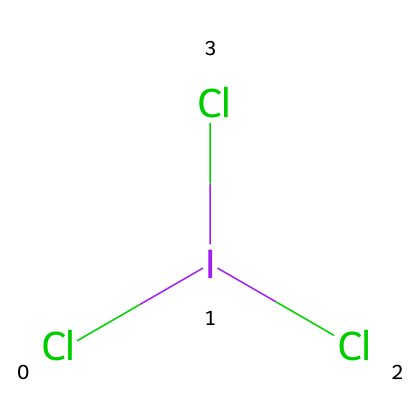What is the total number of chlorine atoms in iodine trichloride? The chemical structure Cl[I](Cl)Cl shows that there are three chlorine atoms bonded to the iodine atom, as indicated by the three Cl groups attached.
Answer: three What is the central atom in the chemical structure of iodine trichloride? Looking at the structure, iodine (I) is the central atom to which the chlorine atoms are bonded; this is evident as it is surrounded by the Cl atoms.
Answer: iodine How many total atoms are present in the chemical structure? Counting all the atoms in Cl[I](Cl)Cl, there are four atoms in total: one iodine (I) and three chlorine (Cl) atoms.
Answer: four Why is iodine trichloride considered a hypervalent compound? Iodine trichloride can accommodate more than eight electrons in its valence shell, specifically having ten electrons (as it is bonded to three chlorine atoms), which is characteristic of hypervalent compounds.
Answer: ten What is a common use of iodine trichloride? Iodine trichloride is commonly utilized in water treatment systems due to its ability to act as a disinfectant.
Answer: disinfectant How many bonds does iodine form in this compound? In the structure Cl[I](Cl)Cl, iodine forms three single bonds to each chlorine atom.
Answer: three 